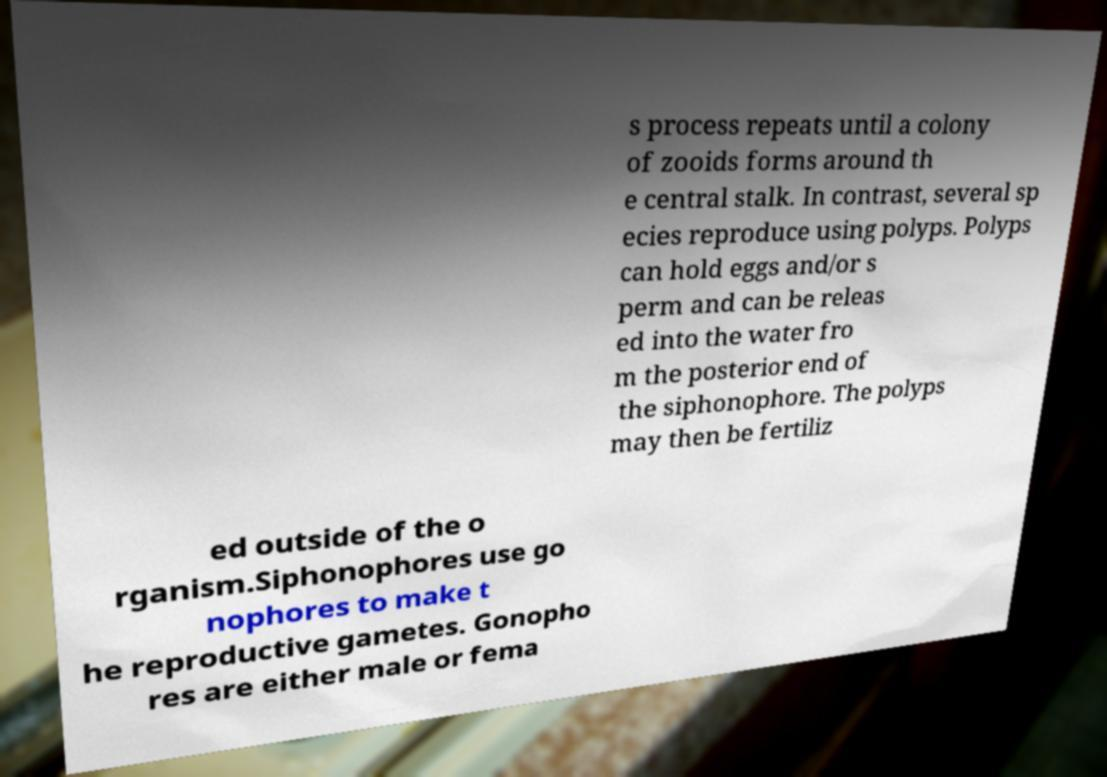Can you read and provide the text displayed in the image?This photo seems to have some interesting text. Can you extract and type it out for me? s process repeats until a colony of zooids forms around th e central stalk. In contrast, several sp ecies reproduce using polyps. Polyps can hold eggs and/or s perm and can be releas ed into the water fro m the posterior end of the siphonophore. The polyps may then be fertiliz ed outside of the o rganism.Siphonophores use go nophores to make t he reproductive gametes. Gonopho res are either male or fema 